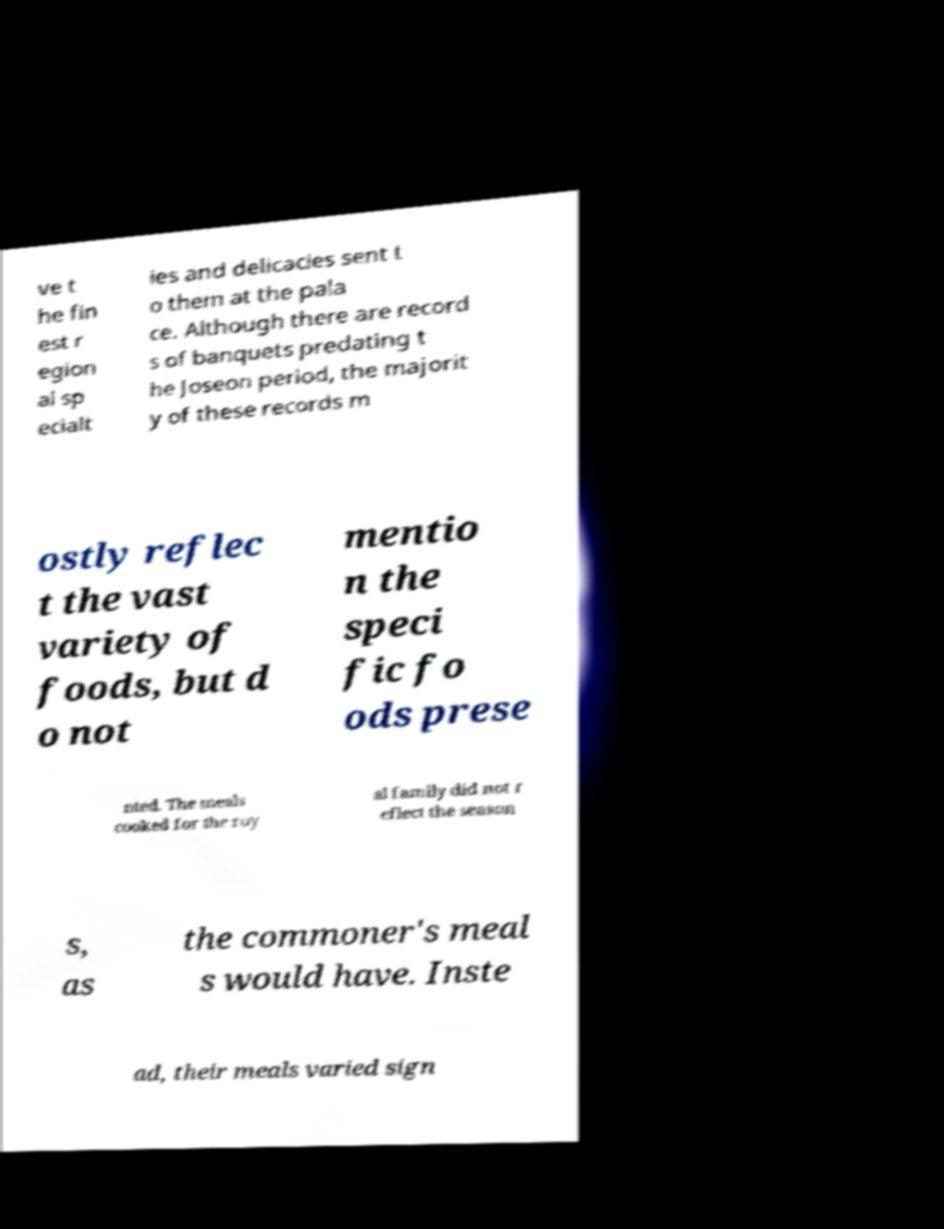Could you assist in decoding the text presented in this image and type it out clearly? ve t he fin est r egion al sp ecialt ies and delicacies sent t o them at the pala ce. Although there are record s of banquets predating t he Joseon period, the majorit y of these records m ostly reflec t the vast variety of foods, but d o not mentio n the speci fic fo ods prese nted. The meals cooked for the roy al family did not r eflect the season s, as the commoner's meal s would have. Inste ad, their meals varied sign 